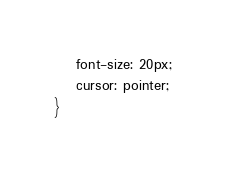<code> <loc_0><loc_0><loc_500><loc_500><_CSS_>    font-size: 20px;
    cursor: pointer;
}</code> 